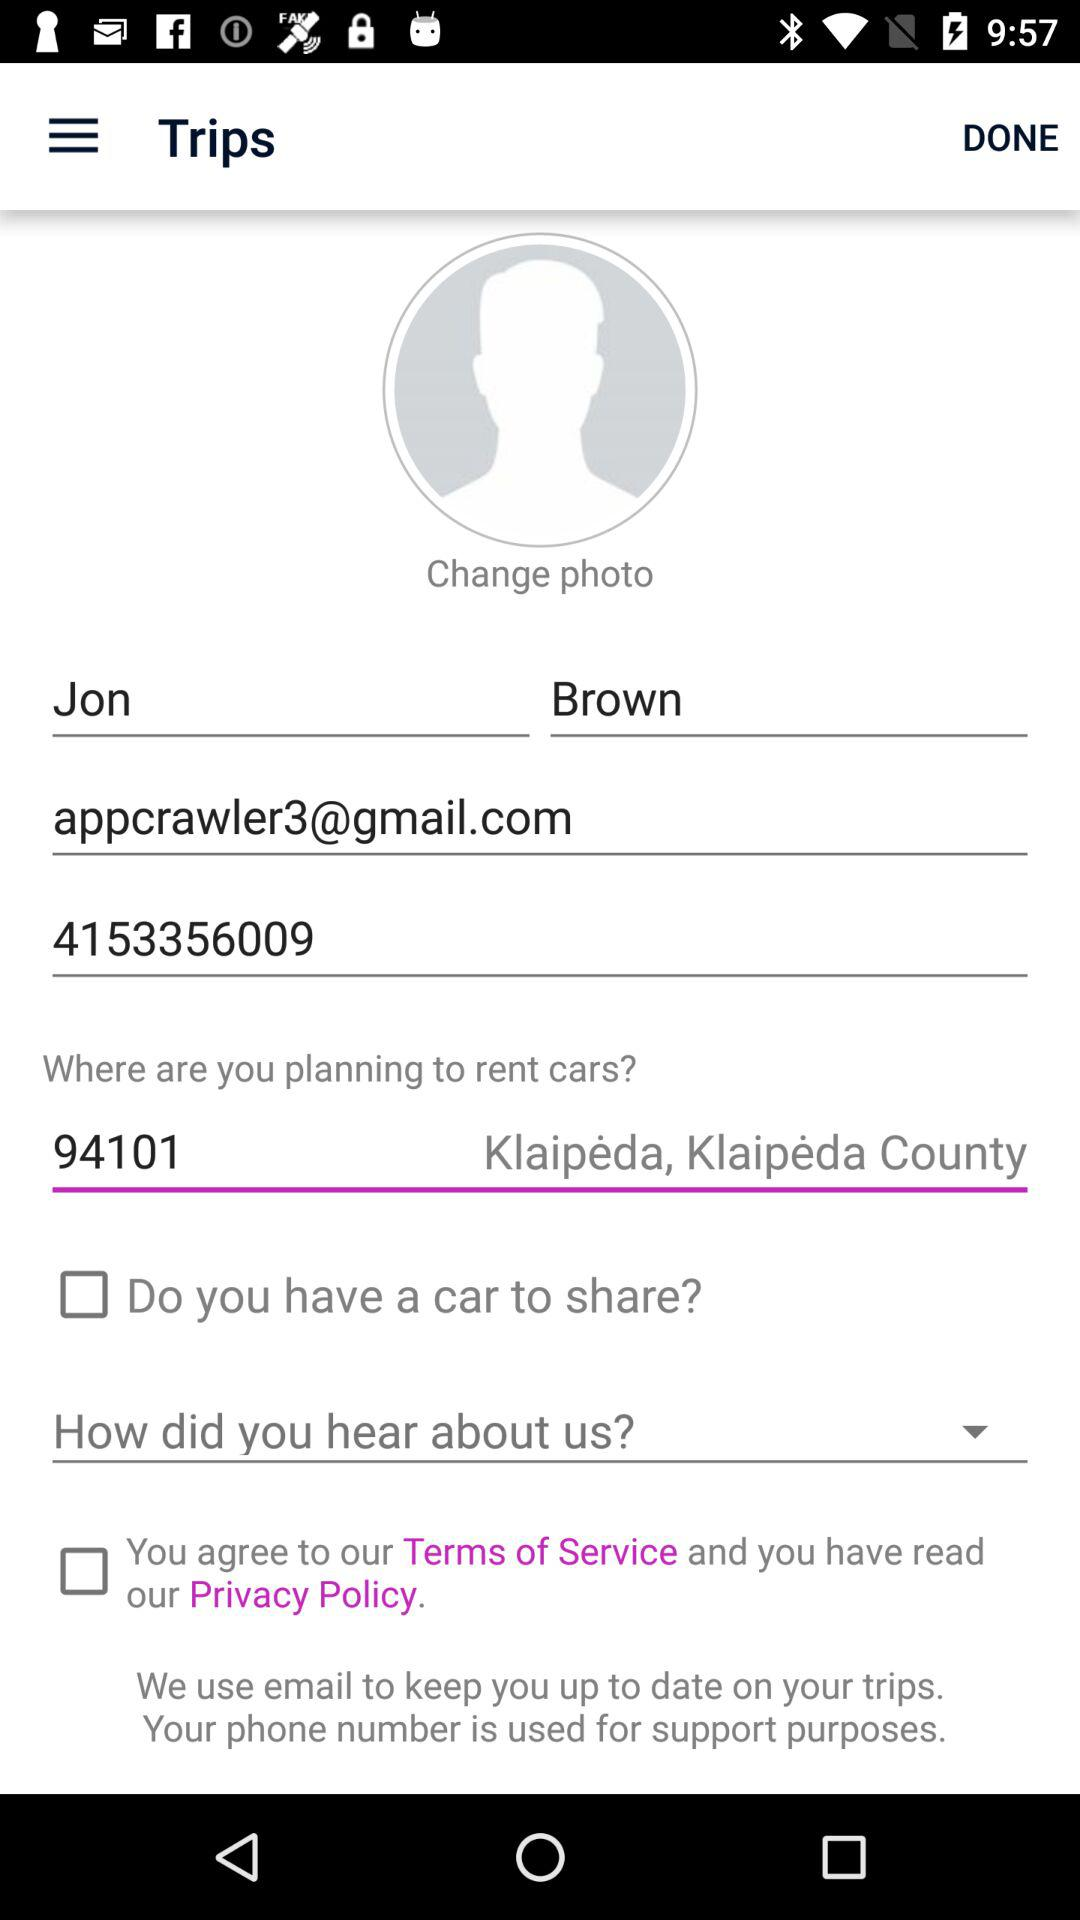How many text inputs have an email address?
Answer the question using a single word or phrase. 1 